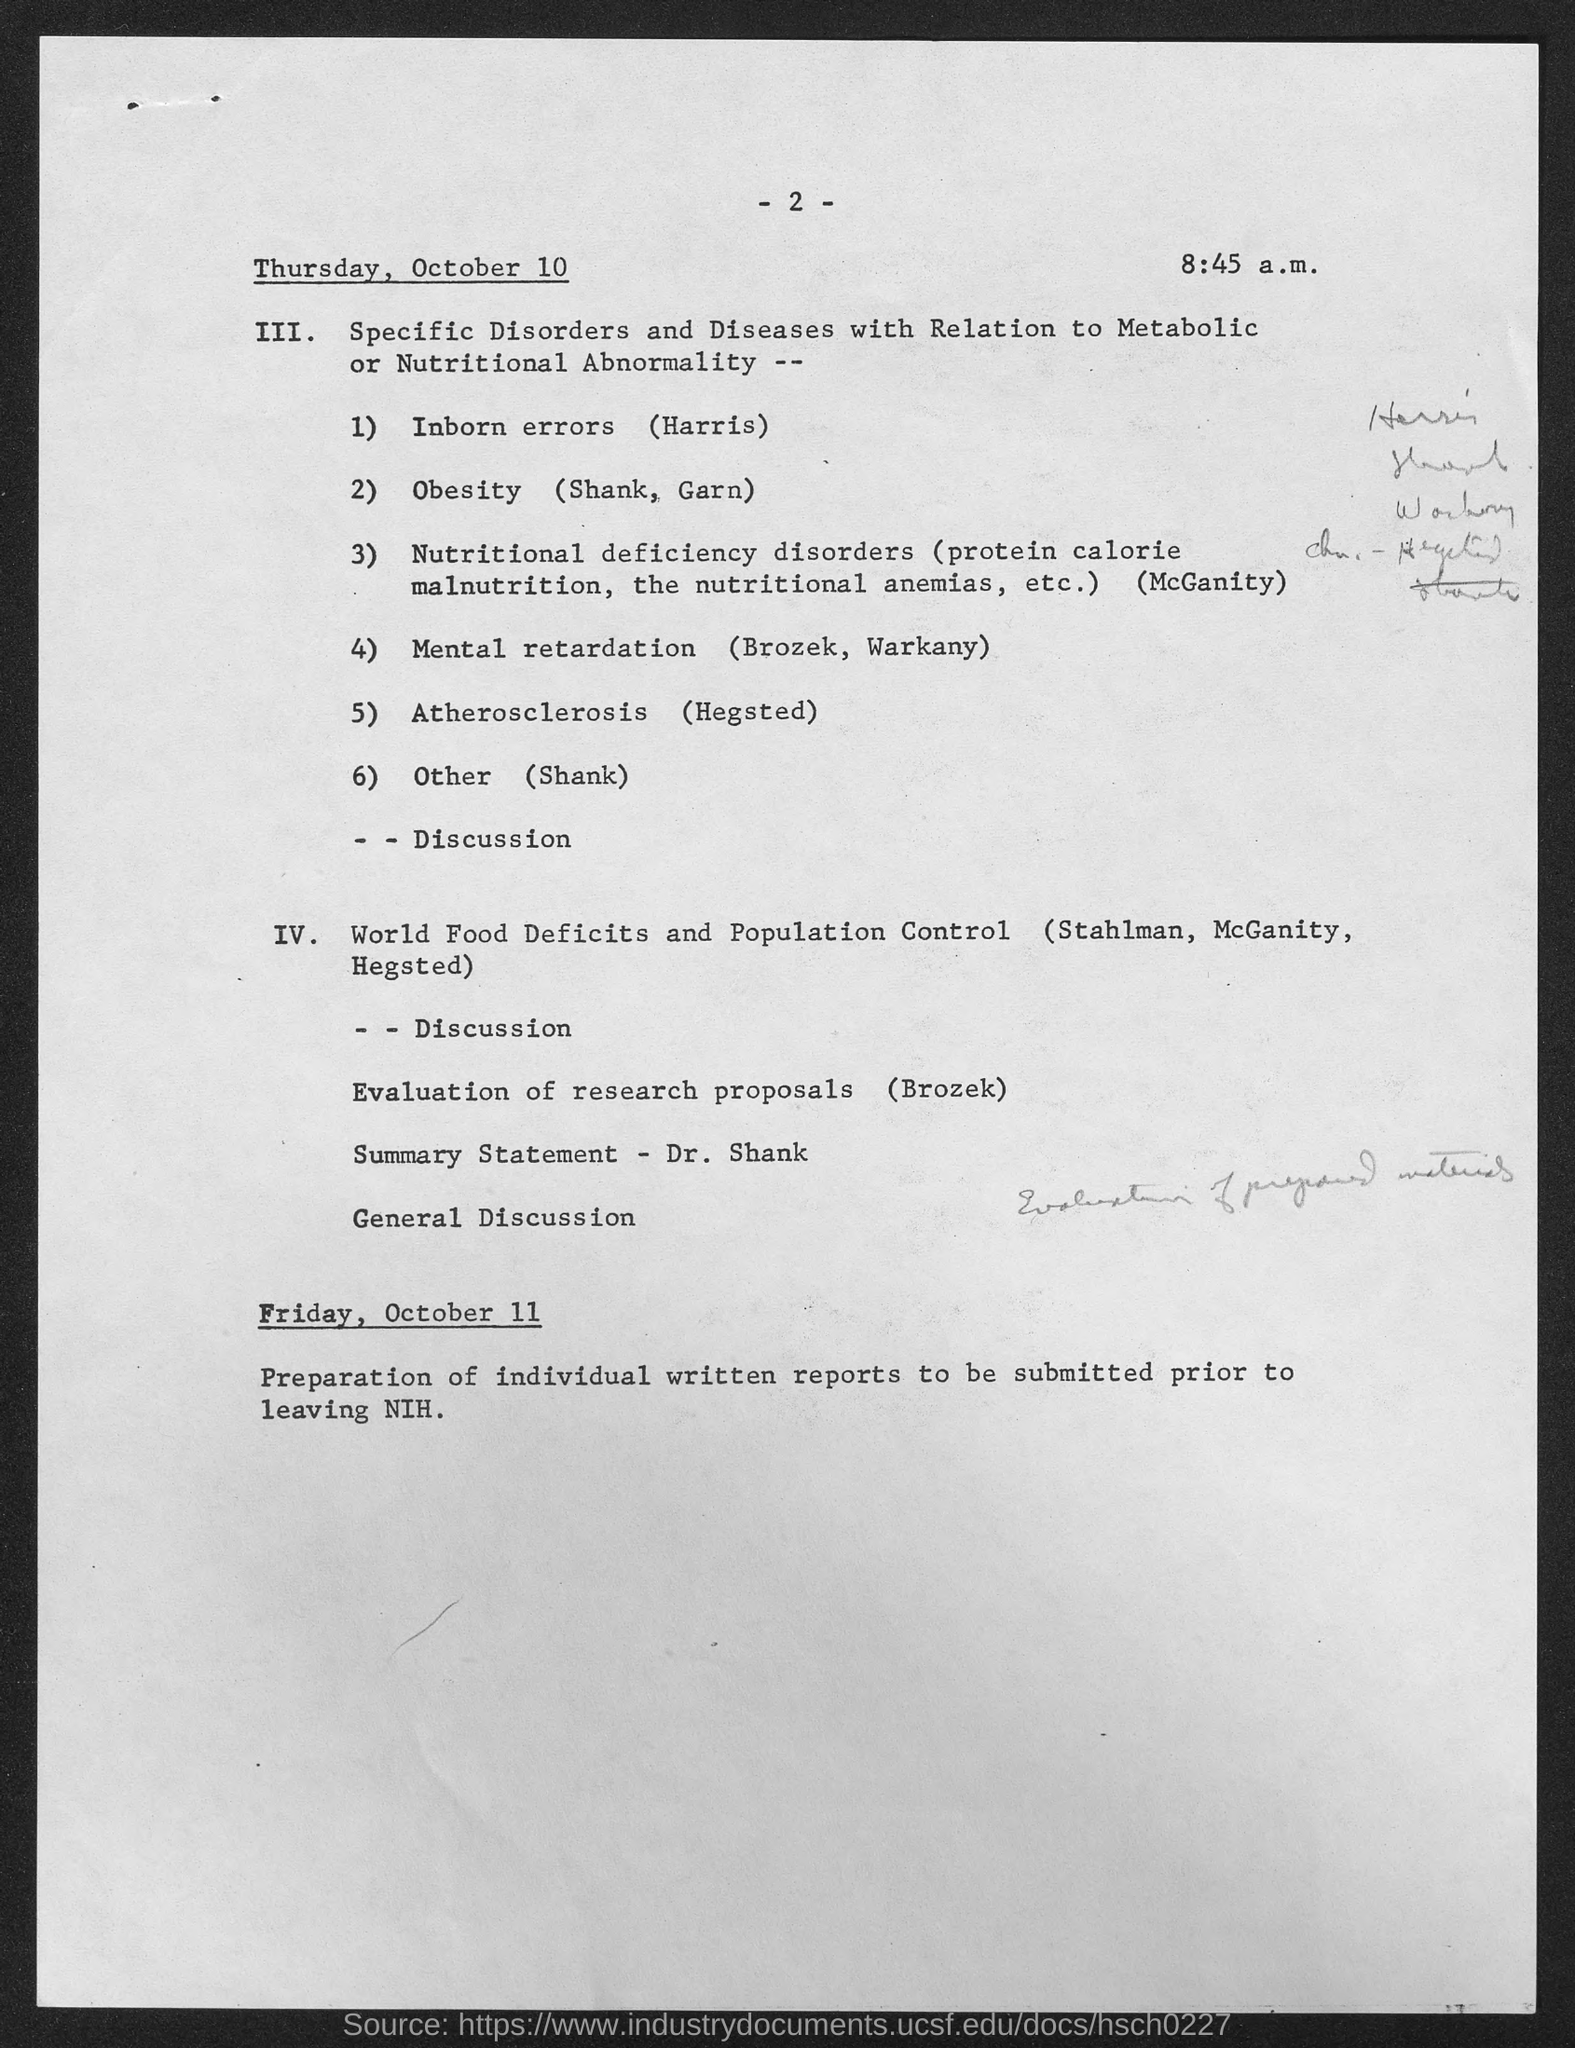Highlight a few significant elements in this photo. The preparation of individual written reports to be submitted prior to leaving NIH is to be done on Friday, October 11. The document mentions the time to be 8:45 a.m. The page number mentioned in this document is 2. 